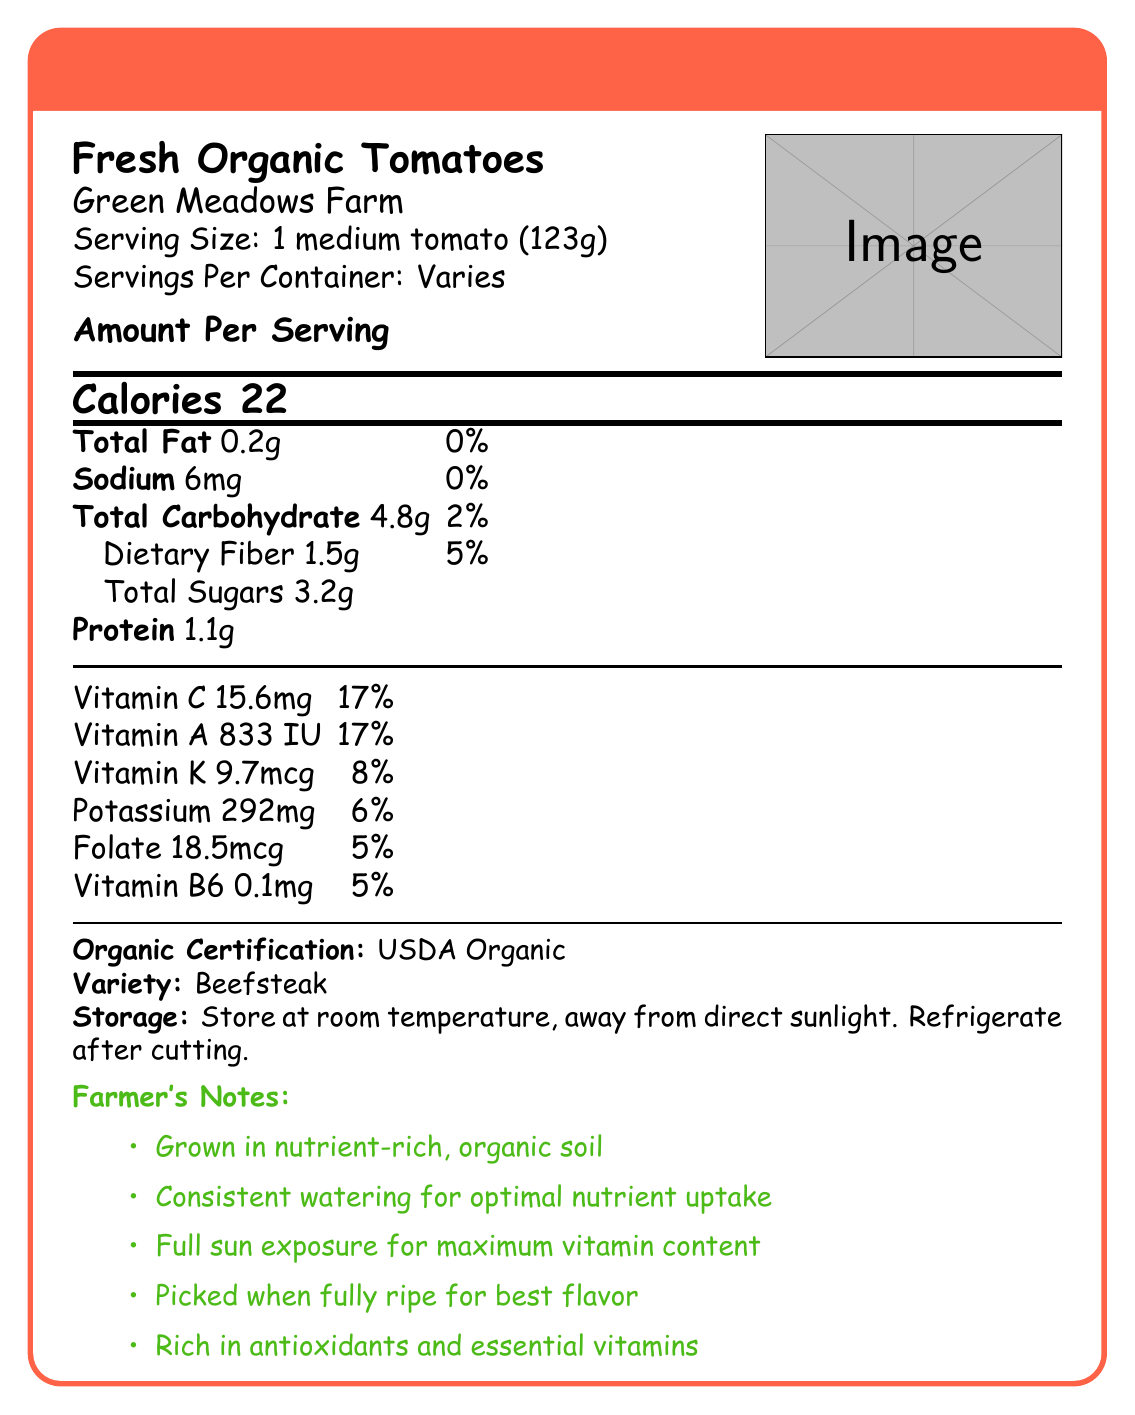what is the serving size for Fresh Organic Tomatoes? The serving size is explicitly mentioned in the document under the "Serving Size" section.
Answer: 1 medium tomato (123g) how many calories are in one serving of Fresh Organic Tomatoes? The document lists the calories per serving in a dedicated section.
Answer: 22 what is the total sugar content per serving? The total sugar content is listed under the "Total Sugars" section in the document.
Answer: 3.2g how much dietary fiber is in one serving, and what is its daily value percentage? The document states that 1 serving contains 1.5g of dietary fiber, which is 5% of the daily value.
Answer: 1.5g, 5% what is the amount of vitamin C in one serving, and what is its daily value percentage? The amount of vitamin C and its daily value percentage are listed under the "Vitamins and Minerals" section.
Answer: 15.6mg, 17% which vitamin has the highest daily value percentage per serving? A. Vitamin C B. Vitamin A C. Vitamin K D. Folate Vitamin C and Vitamin A both have the highest daily value percentage per serving at 17%, but as specified in the question, Vitamin C appears first.
Answer: A. Vitamin C how many milligrams of sodium are in one serving? A. 6mg B. 10mg C. 15mg D. 20mg The sodium content per serving is listed as 6mg in the document.
Answer: A. 6mg are the Fresh Organic Tomatoes USDA Organic certified? The document has a section that claims "Organic Certification: USDA Organic," confirming the certification.
Answer: Yes do Fresh Organic Tomatoes need to be refrigerated before cutting? The storage instructions state to store at room temperature and only refrigerate after cutting.
Answer: No do the Farmer's notes emphasize the importance of full sun exposure for vitamin development? The Farmer's notes mention "Full sun exposure for maximum vitamin development," highlighting its importance.
Answer: Yes how many components does the "Total Carbohydrate" section include, and what are they? The Total Carbohydrate section lists Dietary Fiber (1.5g, 5%) and Total Sugars (3.2g).
Answer: 2, Dietary Fiber and Total Sugars how are Fresh Organic Tomatoes described in terms of antioxidants and essential vitamins? The Farmer's notes section states that the tomatoes are "rich in antioxidants and essential vitamins."
Answer: Rich in antioxidants and essential vitamins describe the entire document or the main idea. The document provides comprehensive nutrition details for Fresh Organic Tomatoes, including serving size, calorie content, fats, carbohydrates, proteins, vitamins, and minerals. It also emphasizes organic certification, proper storage, and tips for optimal growth and harvest from a farmer's perspective.
Answer: The document is a detailed Nutrition Facts Label for Fresh Organic Tomatoes from Green Meadows Farm, highlighting calories, macronutrients, vitamins, and minerals per serving. It includes additional information such as organic certification, storage instructions, and farmer's notes. what is the specific variety of the tomatoes mentioned in the document? The document specifies the variety of the tomatoes under the "Variety" section, which is Beefsteak.
Answer: Beefsteak how often should the Fresh Organic Tomatoes be watered according to the Farmer's notes? The Farmer's notes emphasize a "consistent watering schedule to ensure optimal nutrient uptake."
Answer: Consistently what is the exact harvest date mentioned for the tomatoes? The document states that the harvest date "varies," so it does not provide an exact date.
Answer: Not enough information which vitamin has the least amount per serving? According to the document, Vitamin B6 has the least amount per serving at 0.1mg.
Answer: Vitamin B6 